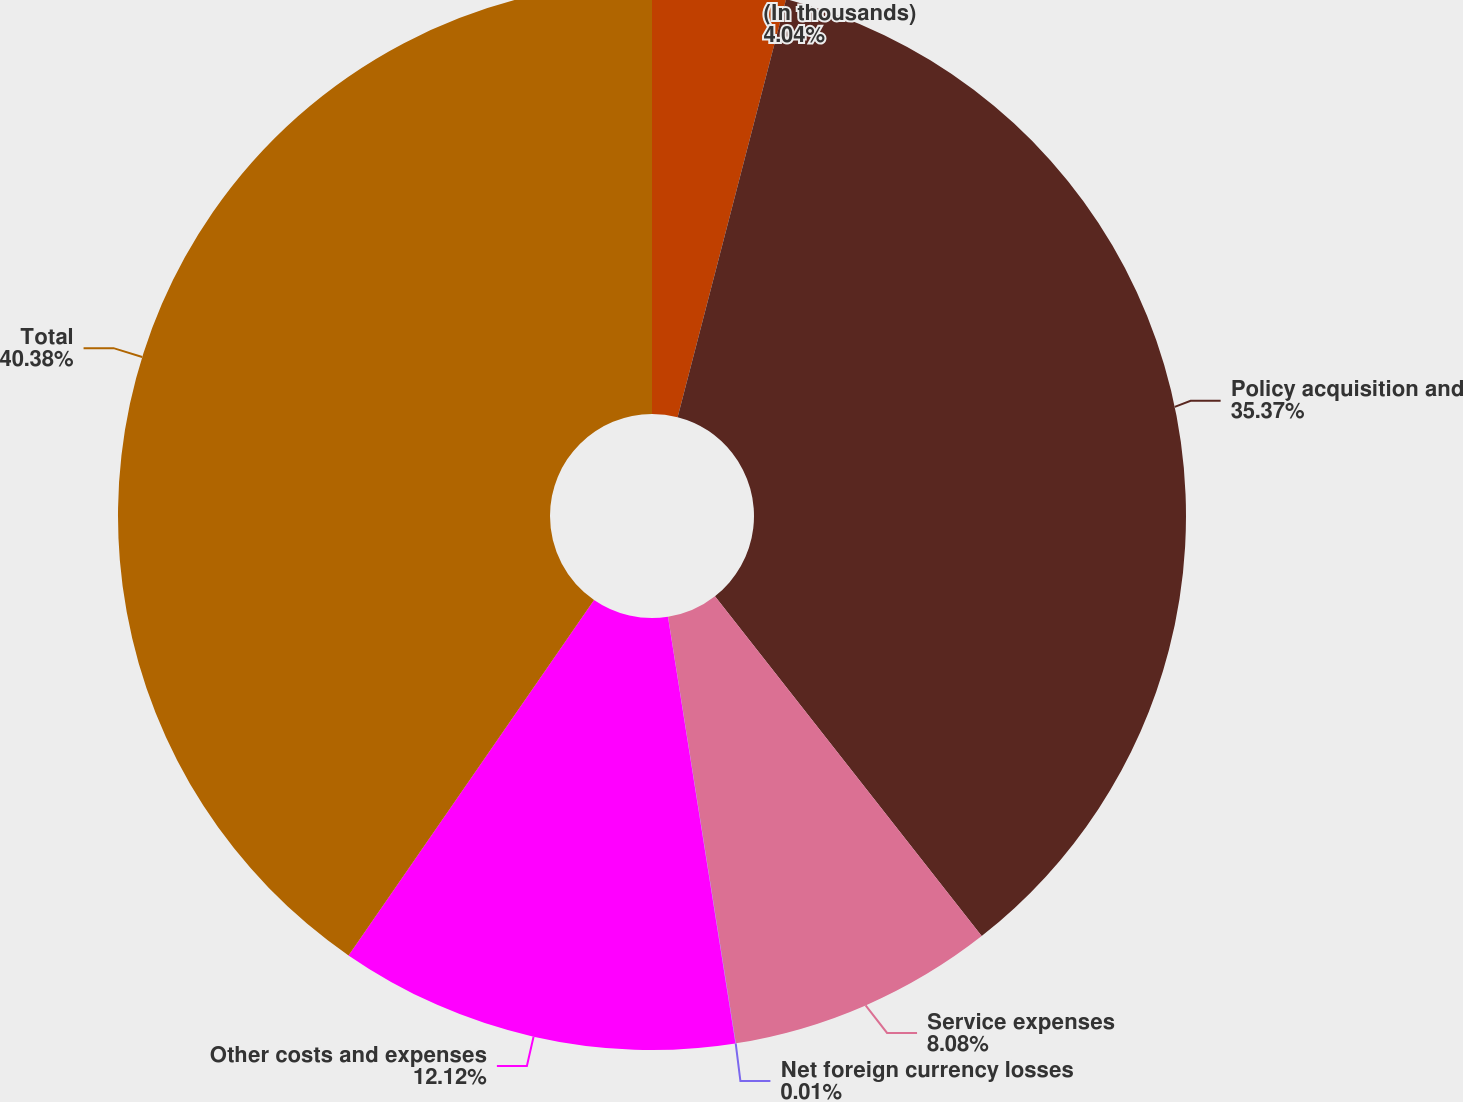Convert chart to OTSL. <chart><loc_0><loc_0><loc_500><loc_500><pie_chart><fcel>(In thousands)<fcel>Policy acquisition and<fcel>Service expenses<fcel>Net foreign currency losses<fcel>Other costs and expenses<fcel>Total<nl><fcel>4.04%<fcel>35.37%<fcel>8.08%<fcel>0.01%<fcel>12.12%<fcel>40.38%<nl></chart> 